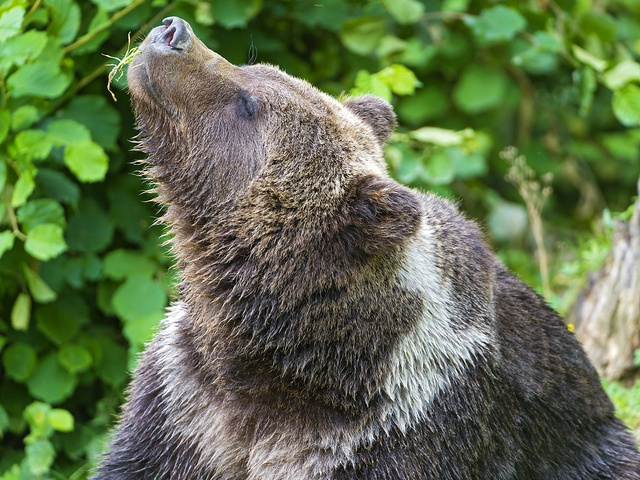Describe the objects in this image and their specific colors. I can see a bear in green, gray, black, darkgray, and lightgray tones in this image. 